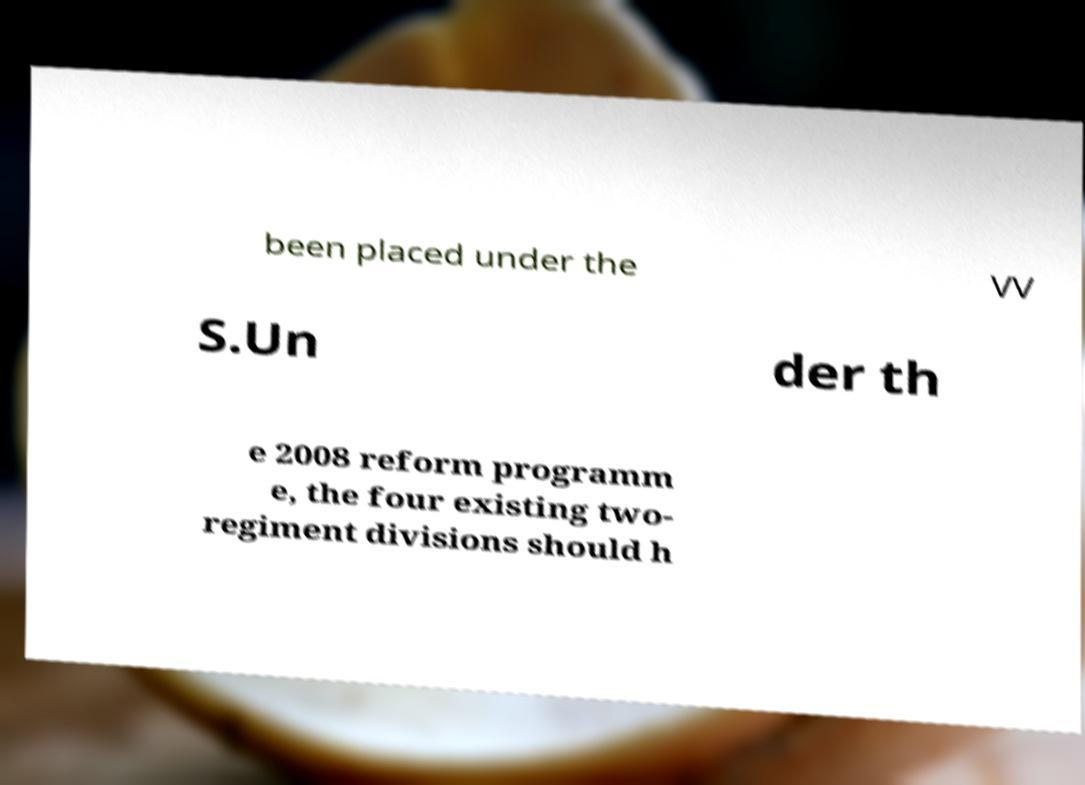For documentation purposes, I need the text within this image transcribed. Could you provide that? been placed under the VV S.Un der th e 2008 reform programm e, the four existing two- regiment divisions should h 